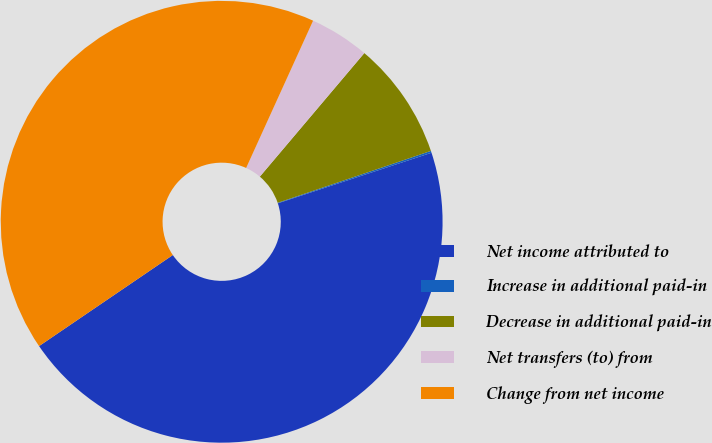<chart> <loc_0><loc_0><loc_500><loc_500><pie_chart><fcel>Net income attributed to<fcel>Increase in additional paid-in<fcel>Decrease in additional paid-in<fcel>Net transfers (to) from<fcel>Change from net income<nl><fcel>45.54%<fcel>0.14%<fcel>8.63%<fcel>4.38%<fcel>41.3%<nl></chart> 